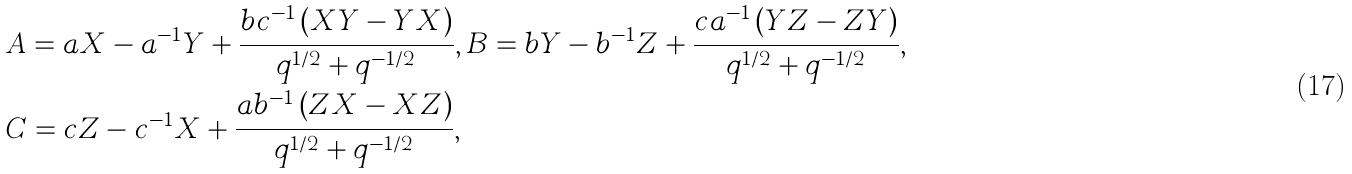<formula> <loc_0><loc_0><loc_500><loc_500>& A = a X - a ^ { - 1 } Y + \frac { b c ^ { - 1 } \left ( X Y - Y X \right ) } { q ^ { 1 / 2 } + q ^ { - 1 / 2 } } , B = b Y - b ^ { - 1 } Z + \frac { c a ^ { - 1 } \left ( Y Z - Z Y \right ) } { q ^ { 1 / 2 } + q ^ { - 1 / 2 } } , \\ & C = c Z - c ^ { - 1 } X + \frac { a b ^ { - 1 } \left ( Z X - X Z \right ) } { q ^ { 1 / 2 } + q ^ { - 1 / 2 } } ,</formula> 